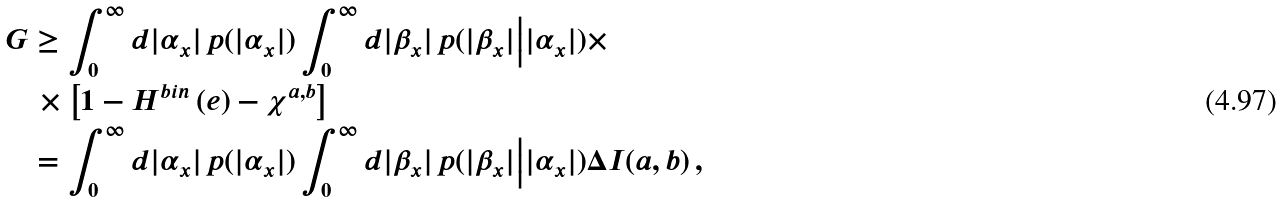Convert formula to latex. <formula><loc_0><loc_0><loc_500><loc_500>G & \geq \int _ { 0 } ^ { \infty } d | \alpha _ { x } | \, p ( | \alpha _ { x } | ) \int _ { 0 } ^ { \infty } d | \beta _ { x } | \, p ( | \beta _ { x } | \Big { | } | \alpha _ { x } | ) \times \\ & \, \times \left [ 1 - H ^ { b i n } \left ( e \right ) - \chi ^ { a , b } \right ] \\ & = \int _ { 0 } ^ { \infty } d | \alpha _ { x } | \, p ( | \alpha _ { x } | ) \int _ { 0 } ^ { \infty } d | \beta _ { x } | \, p ( | \beta _ { x } | \Big { | } | \alpha _ { x } | ) \Delta I ( a , b ) \, ,</formula> 